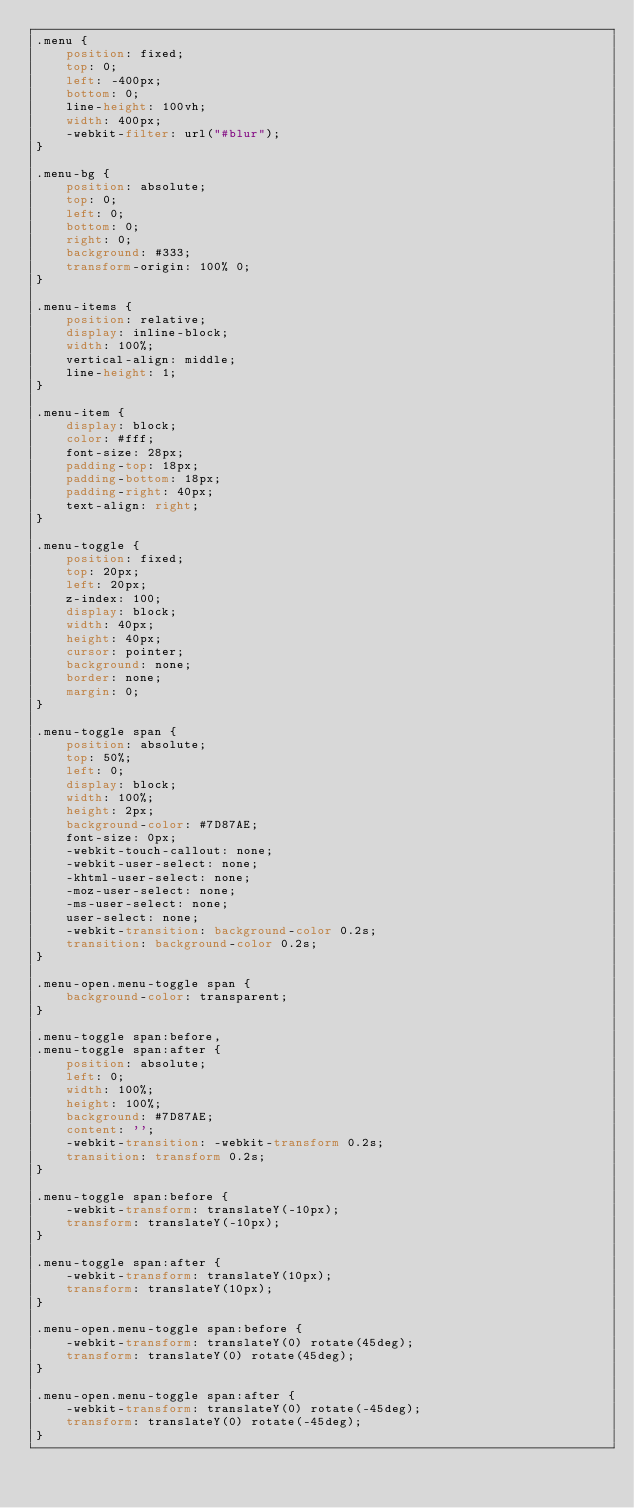<code> <loc_0><loc_0><loc_500><loc_500><_CSS_>.menu {
	position: fixed;
	top: 0;
	left: -400px;
	bottom: 0;
	line-height: 100vh;
	width: 400px;
	-webkit-filter: url("#blur");
}

.menu-bg {
	position: absolute;
	top: 0;
	left: 0;
	bottom: 0;
	right: 0;
	background: #333;
	transform-origin: 100% 0;
}

.menu-items {
	position: relative;
	display: inline-block;
	width: 100%;
	vertical-align: middle;
	line-height: 1;
}

.menu-item {
	display: block;
	color: #fff;
	font-size: 28px;
	padding-top: 18px;
	padding-bottom: 18px;
	padding-right: 40px;
	text-align: right;
}

.menu-toggle {
	position: fixed;
	top: 20px;
	left: 20px;
	z-index: 100;
	display: block;
	width: 40px;
	height: 40px;
	cursor: pointer;
	background: none;
	border: none;
	margin: 0;
}

.menu-toggle span {
	position: absolute;
	top: 50%;
	left: 0;
	display: block;
	width: 100%;
	height: 2px;
	background-color: #7D87AE;
	font-size: 0px;
	-webkit-touch-callout: none;
	-webkit-user-select: none;
	-khtml-user-select: none;
	-moz-user-select: none;
	-ms-user-select: none;
	user-select: none;
	-webkit-transition: background-color 0.2s;
	transition: background-color 0.2s;
}

.menu-open.menu-toggle span {
	background-color: transparent;
}

.menu-toggle span:before,
.menu-toggle span:after {
	position: absolute;
	left: 0;
	width: 100%;
	height: 100%;
	background: #7D87AE;
	content: '';
	-webkit-transition: -webkit-transform 0.2s;
	transition: transform 0.2s;
}

.menu-toggle span:before {
	-webkit-transform: translateY(-10px);
	transform: translateY(-10px);
}

.menu-toggle span:after {
	-webkit-transform: translateY(10px);
	transform: translateY(10px);
}

.menu-open.menu-toggle span:before {
	-webkit-transform: translateY(0) rotate(45deg);
	transform: translateY(0) rotate(45deg);
}

.menu-open.menu-toggle span:after {
	-webkit-transform: translateY(0) rotate(-45deg);
	transform: translateY(0) rotate(-45deg);
}
</code> 